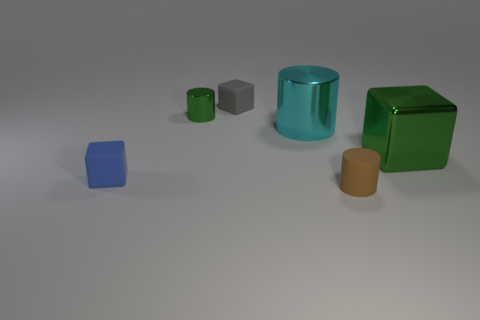Is the material of the tiny green object the same as the block that is left of the small gray rubber thing?
Keep it short and to the point. No. Is the material of the gray object the same as the large green cube?
Offer a very short reply. No. There is a green metallic thing right of the matte cylinder; are there any tiny gray cubes to the right of it?
Your answer should be very brief. No. What number of matte things are both to the left of the small green metallic object and behind the big shiny block?
Provide a short and direct response. 0. The large metallic object that is on the left side of the brown matte cylinder has what shape?
Your answer should be compact. Cylinder. What number of blue blocks are the same size as the brown rubber cylinder?
Your answer should be compact. 1. Does the cube to the left of the tiny gray matte block have the same color as the big metal cylinder?
Make the answer very short. No. There is a cube that is in front of the gray rubber cube and left of the big cyan cylinder; what is it made of?
Your answer should be very brief. Rubber. Are there more small cylinders than small yellow cylinders?
Offer a very short reply. Yes. What is the color of the tiny block behind the green object that is to the right of the block behind the cyan cylinder?
Your answer should be very brief. Gray. 